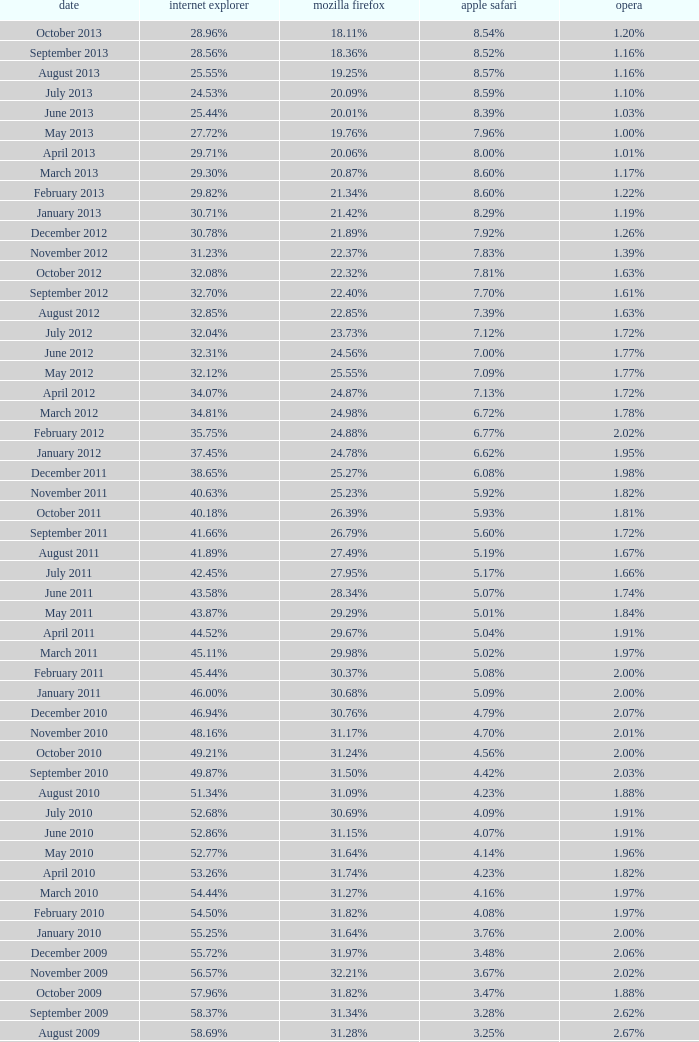What percentage of browsers were using Opera in October 2010? 2.00%. 